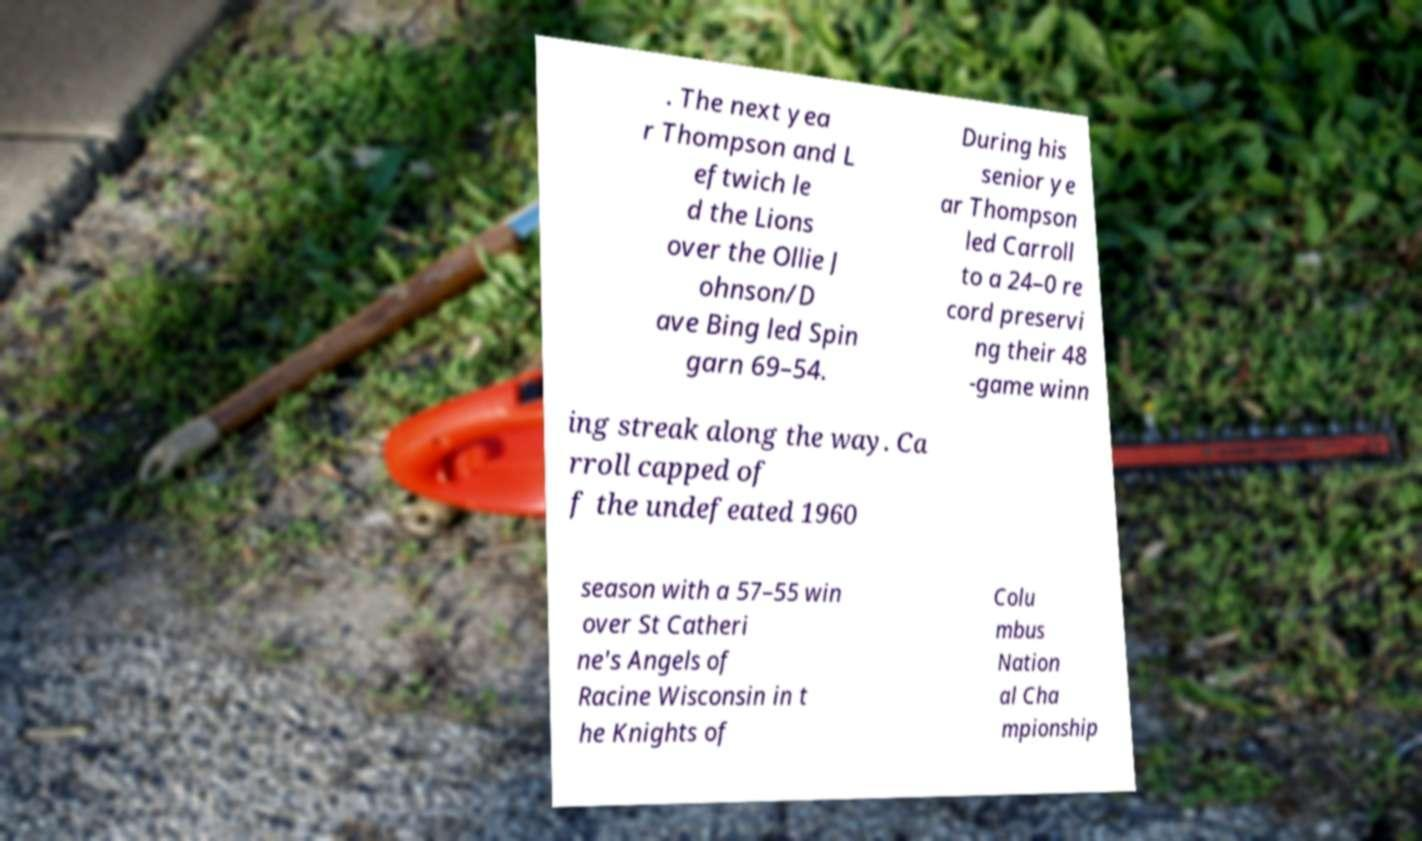Could you extract and type out the text from this image? . The next yea r Thompson and L eftwich le d the Lions over the Ollie J ohnson/D ave Bing led Spin garn 69–54. During his senior ye ar Thompson led Carroll to a 24–0 re cord preservi ng their 48 -game winn ing streak along the way. Ca rroll capped of f the undefeated 1960 season with a 57–55 win over St Catheri ne's Angels of Racine Wisconsin in t he Knights of Colu mbus Nation al Cha mpionship 